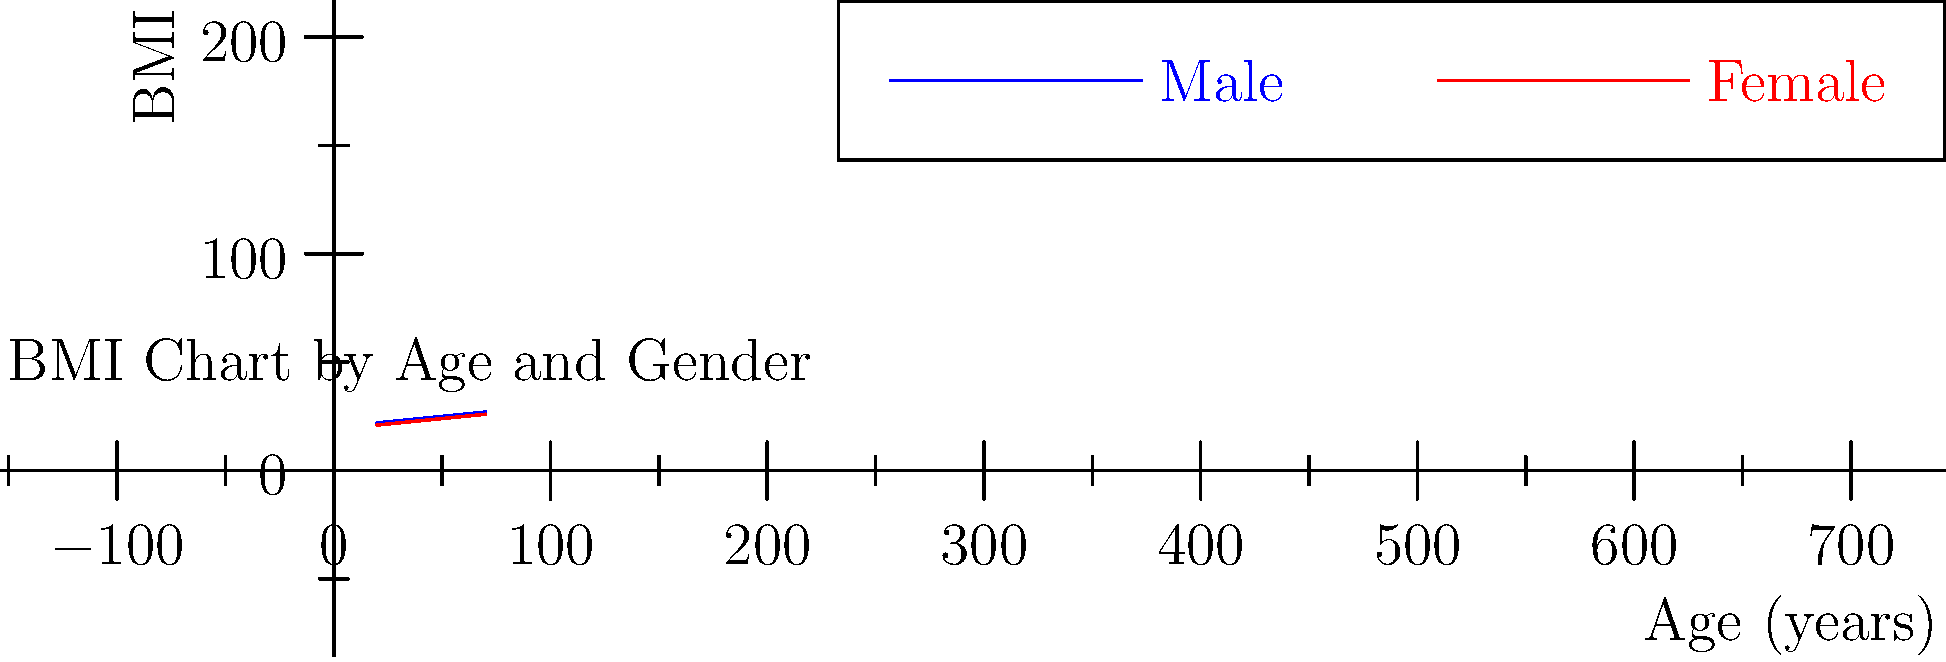Based on the BMI chart provided, which of the following statements is most accurate regarding the BMI trends across age groups and genders? To answer this question, let's analyze the chart step-by-step:

1. The chart shows BMI trends for males (blue line) and females (red line) across different age groups.

2. Age range: The x-axis shows ages from 20 to 70 years.

3. BMI range: The y-axis shows BMI values from approximately 21 to 27.

4. Male trend:
   - Starts at a BMI of 22 at age 20
   - Increases steadily with age
   - Reaches a BMI of 27 at age 70

5. Female trend:
   - Starts at a BMI of 21 at age 20
   - Increases steadily with age
   - Reaches a BMI of 26 at age 70

6. Comparing trends:
   - Both genders show an increasing BMI trend with age
   - Males consistently have a higher BMI than females across all age groups
   - The gap between male and female BMI remains relatively constant (about 1 BMI point)

7. Rate of increase:
   - Both genders show a similar rate of BMI increase with age
   - The increase appears to be roughly linear

Based on these observations, the most accurate statement is that BMI increases with age for both genders, with males consistently having a higher BMI than females across all age groups.
Answer: BMI increases with age for both genders; males consistently have higher BMI than females. 